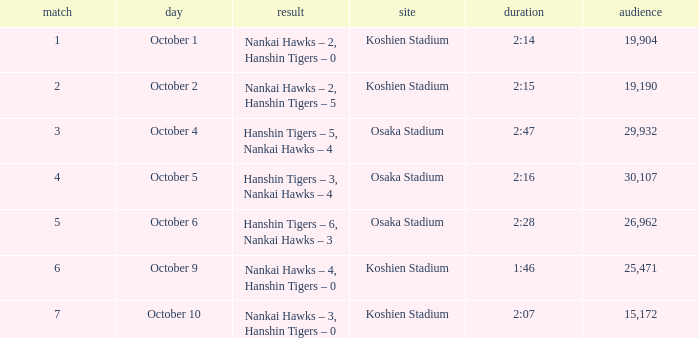How many games had a Time of 2:14? 1.0. 